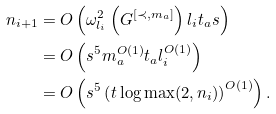<formula> <loc_0><loc_0><loc_500><loc_500>n _ { i + 1 } & = O \left ( \omega ^ { 2 } _ { l _ { i } } \left ( G ^ { [ \prec , m _ { a } ] } \right ) l _ { i } t _ { a } s \right ) \\ & = O \left ( s ^ { 5 } m _ { a } ^ { O ( 1 ) } t _ { a } l ^ { O ( 1 ) } _ { i } \right ) \\ & = O \left ( s ^ { 5 } \left ( t \log \max ( 2 , n _ { i } ) \right ) ^ { O ( 1 ) } \right ) .</formula> 